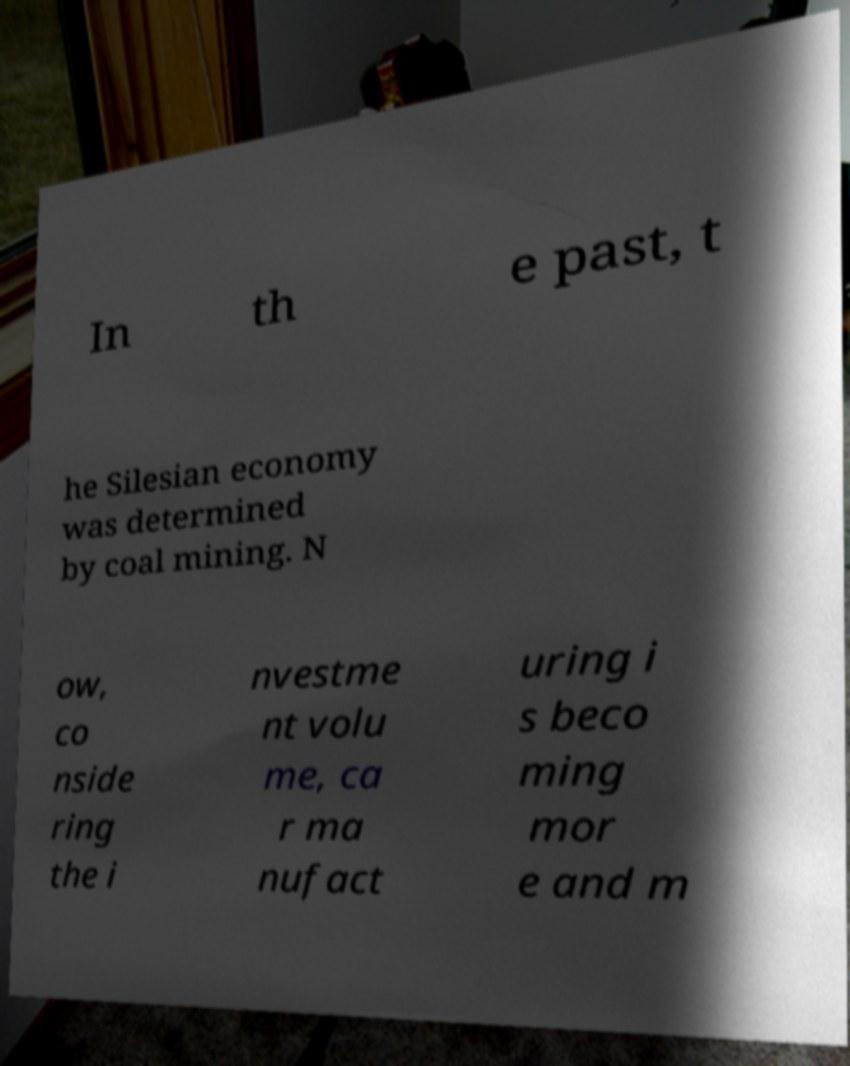Please read and relay the text visible in this image. What does it say? In th e past, t he Silesian economy was determined by coal mining. N ow, co nside ring the i nvestme nt volu me, ca r ma nufact uring i s beco ming mor e and m 